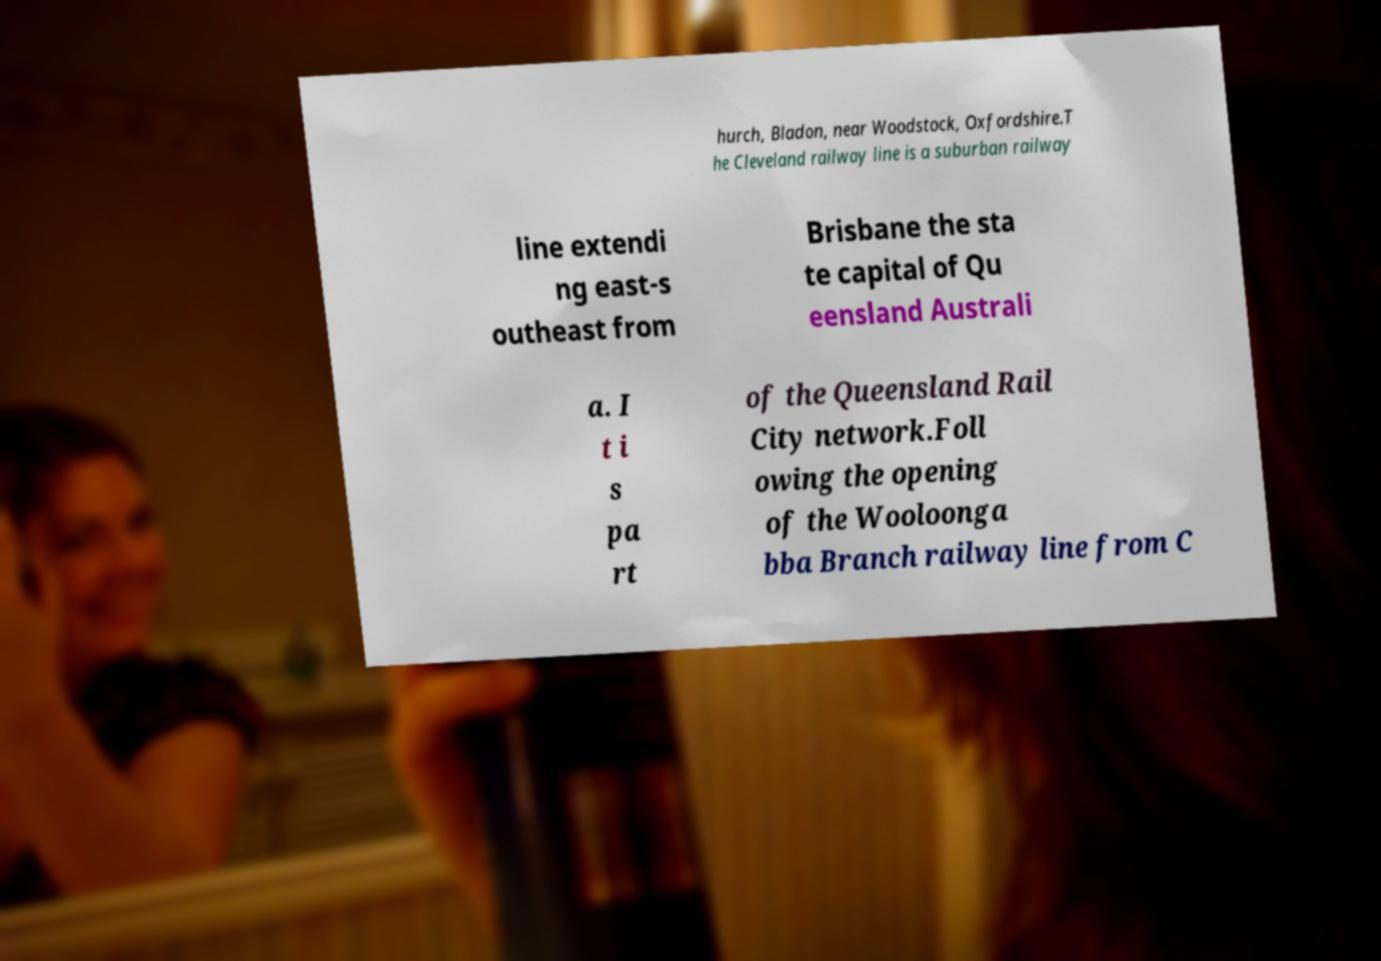What messages or text are displayed in this image? I need them in a readable, typed format. hurch, Bladon, near Woodstock, Oxfordshire.T he Cleveland railway line is a suburban railway line extendi ng east-s outheast from Brisbane the sta te capital of Qu eensland Australi a. I t i s pa rt of the Queensland Rail City network.Foll owing the opening of the Wooloonga bba Branch railway line from C 